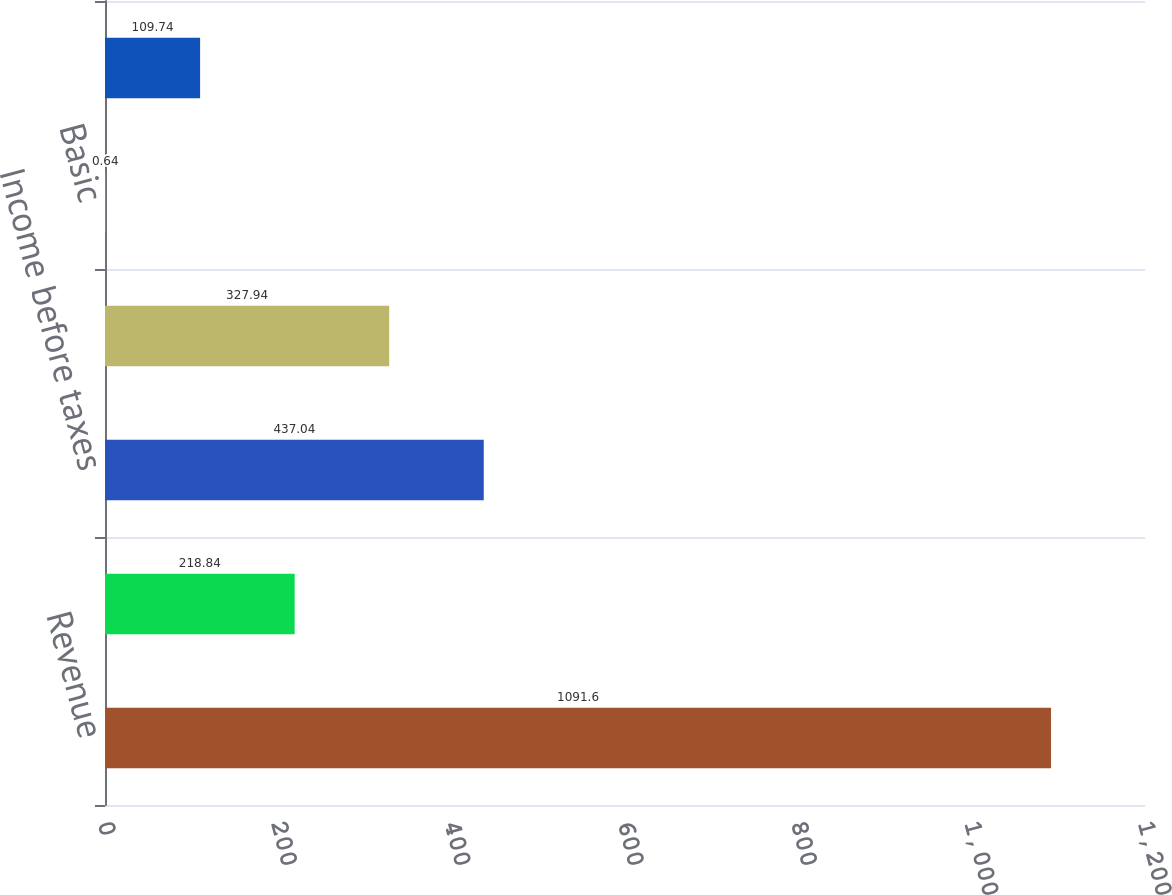<chart> <loc_0><loc_0><loc_500><loc_500><bar_chart><fcel>Revenue<fcel>Operating income<fcel>Income before taxes<fcel>Net income<fcel>Basic<fcel>Diluted<nl><fcel>1091.6<fcel>218.84<fcel>437.04<fcel>327.94<fcel>0.64<fcel>109.74<nl></chart> 